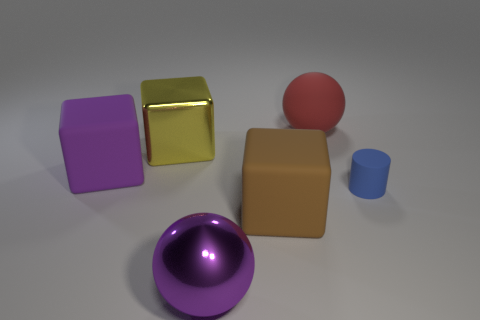Is there anything else that has the same size as the blue matte cylinder?
Ensure brevity in your answer.  No. Is there a big thing of the same color as the large metallic ball?
Provide a succinct answer. Yes. There is a object that is the same color as the large metal ball; what size is it?
Your answer should be very brief. Large. What shape is the metal object that is behind the big ball in front of the big purple matte block?
Offer a very short reply. Cube. There is a purple matte thing; is its shape the same as the big metal object that is to the left of the big purple metal ball?
Provide a succinct answer. Yes. What color is the metallic cube that is the same size as the red rubber sphere?
Provide a short and direct response. Yellow. Is the number of purple balls on the left side of the large red sphere less than the number of blocks in front of the large yellow metal thing?
Provide a short and direct response. Yes. What is the shape of the shiny thing to the left of the big sphere in front of the ball that is behind the small blue cylinder?
Your answer should be compact. Cube. There is a sphere on the right side of the purple metallic object; is it the same color as the big block that is in front of the tiny blue rubber object?
Offer a very short reply. No. What is the shape of the matte object that is the same color as the metal sphere?
Provide a succinct answer. Cube. 